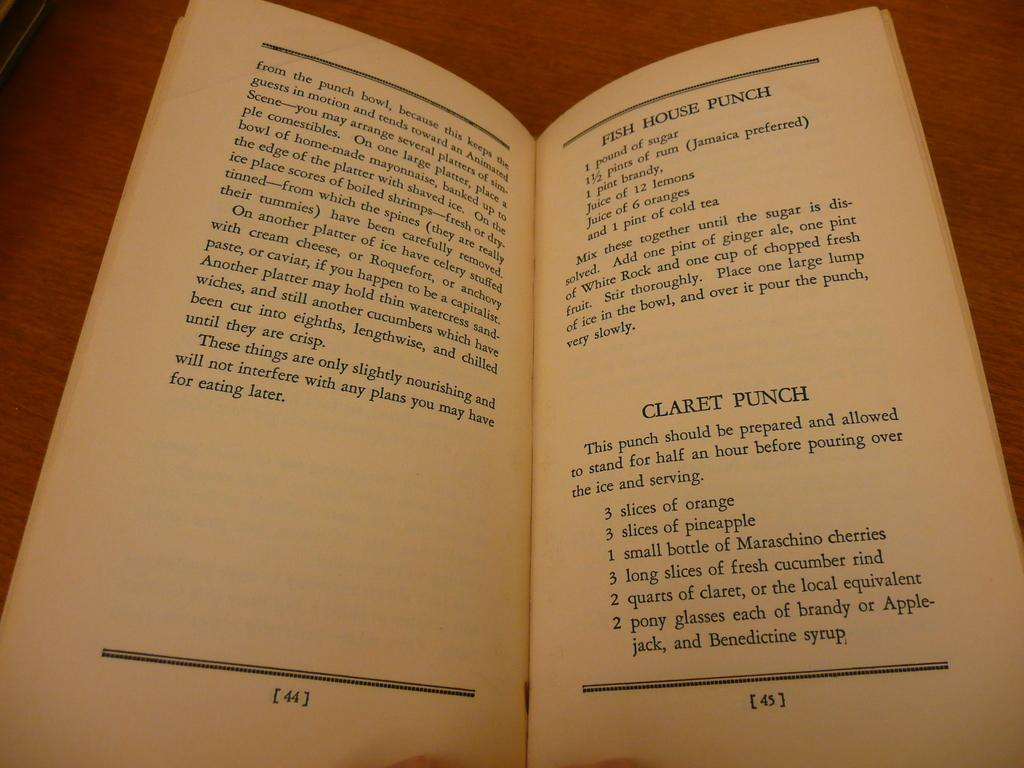<image>
Summarize the visual content of the image. A old recipe book opened to the pages of two different punches. 